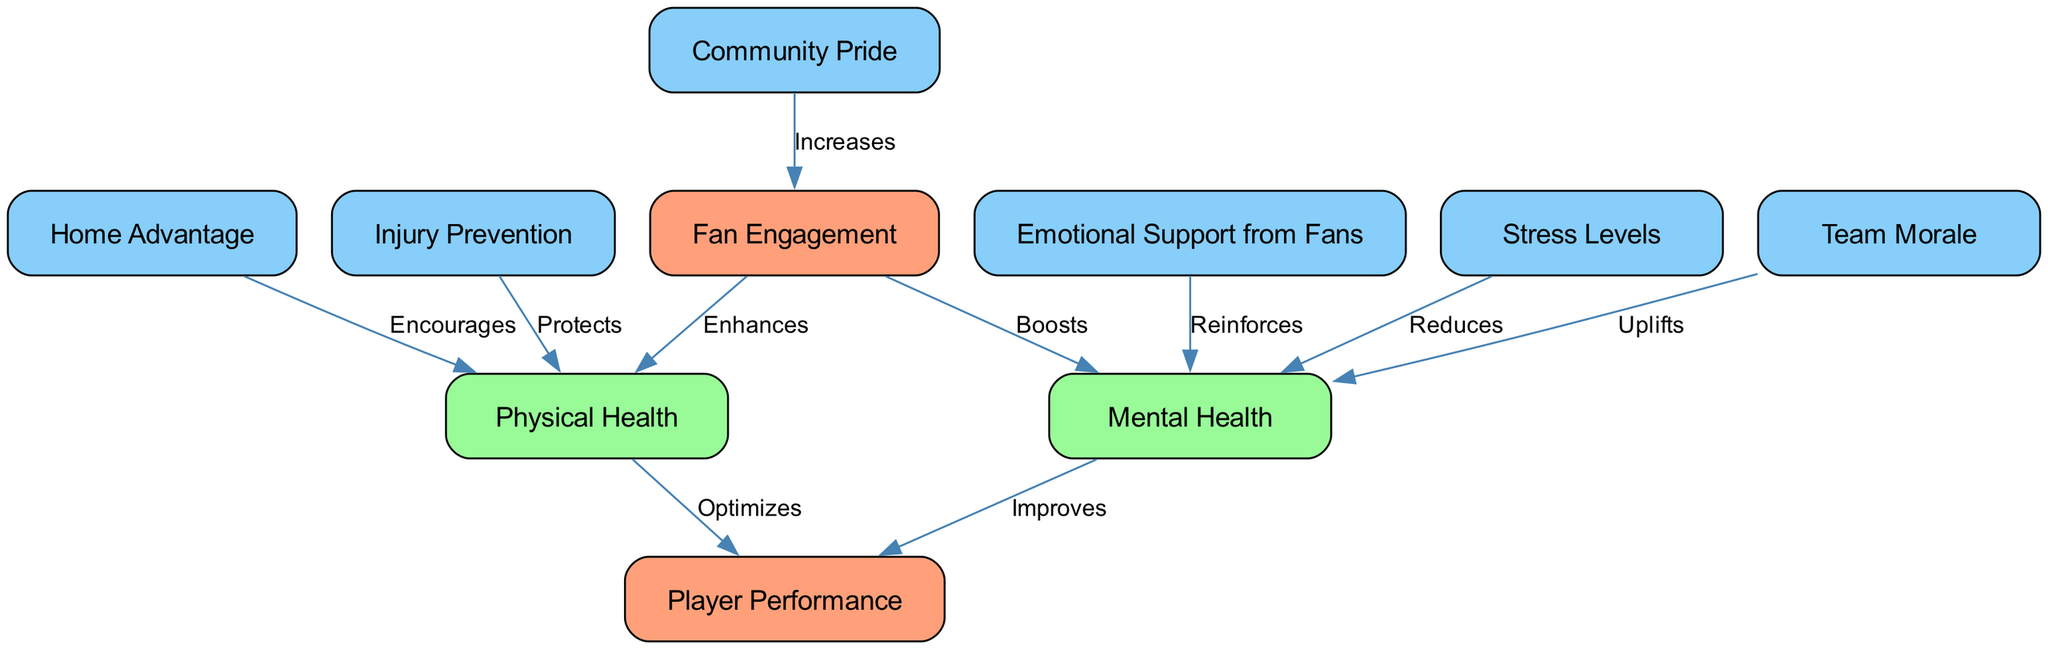What are the labels of the nodes in the diagram? The diagram contains several nodes, each labeled with specific concepts: "Fan Engagement", "Player Performance", "Mental Health", "Physical Health", "Emotional Support from Fans", "Home Advantage", "Stress Levels", "Injury Prevention", "Community Pride", and "Team Morale".
Answer: Fan Engagement, Player Performance, Mental Health, Physical Health, Emotional Support from Fans, Home Advantage, Stress Levels, Injury Prevention, Community Pride, Team Morale How many edges are in the diagram? By counting the connections between the nodes, we find that there are a total of 10 edges shown in the diagram, representing various relationships between the concepts.
Answer: 10 What does "Fan Engagement" boost? The diagram indicates that "Fan Engagement" boosts "Mental Health", as shown by the directed edge connecting these two nodes.
Answer: Mental Health Which node is connected to "Community Pride"? "Community Pride" is connected to "Fan Engagement", as indicated by the edge that originates from "Community Pride" and points towards "Fan Engagement".
Answer: Fan Engagement What relationship does "Stress Levels" have with "Mental Health"? The diagram shows that "Stress Levels" reduces "Mental Health", as represented by the directed edge linking these two nodes, indicating a negative relationship.
Answer: Reduces How does "Home Advantage" impact "Physical Health"? According to the diagram, "Home Advantage" encourages "Physical Health", as indicated by the edge that points from "Home Advantage" to "Physical Health".
Answer: Encourages Which two factors directly improve "Player Performance"? The diagram highlights that "Mental Health" and "Physical Health" both directly lead to improvements in "Player Performance", as shown by the edges connecting these nodes.
Answer: Mental Health, Physical Health What node uplifts "Mental Health"? The diagram shows that "Team Morale" uplifts "Mental Health", as indicated by the directed edge connecting these two nodes which implies a supportive relationship.
Answer: Team Morale What effect does "Emotional Support from Fans" have on "Mental Health"? From the diagram, it is clear that "Emotional Support from Fans" reinforces "Mental Health", as indicated by the edge leading from "Emotional Support from Fans" to "Mental Health".
Answer: Reinforces 